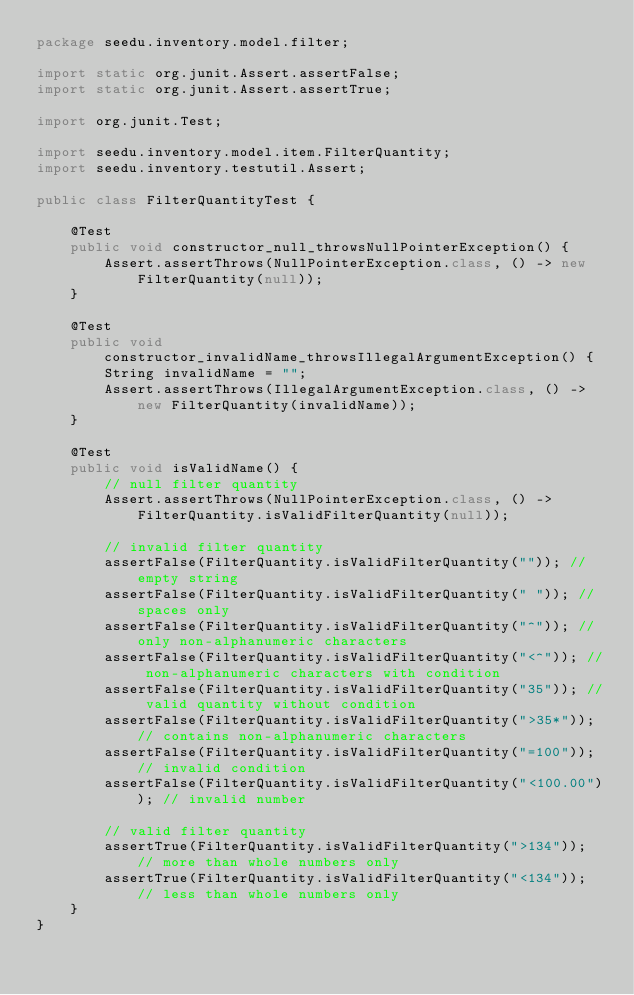<code> <loc_0><loc_0><loc_500><loc_500><_Java_>package seedu.inventory.model.filter;

import static org.junit.Assert.assertFalse;
import static org.junit.Assert.assertTrue;

import org.junit.Test;

import seedu.inventory.model.item.FilterQuantity;
import seedu.inventory.testutil.Assert;

public class FilterQuantityTest {

    @Test
    public void constructor_null_throwsNullPointerException() {
        Assert.assertThrows(NullPointerException.class, () -> new FilterQuantity(null));
    }

    @Test
    public void constructor_invalidName_throwsIllegalArgumentException() {
        String invalidName = "";
        Assert.assertThrows(IllegalArgumentException.class, () -> new FilterQuantity(invalidName));
    }

    @Test
    public void isValidName() {
        // null filter quantity
        Assert.assertThrows(NullPointerException.class, () -> FilterQuantity.isValidFilterQuantity(null));

        // invalid filter quantity
        assertFalse(FilterQuantity.isValidFilterQuantity("")); // empty string
        assertFalse(FilterQuantity.isValidFilterQuantity(" ")); // spaces only
        assertFalse(FilterQuantity.isValidFilterQuantity("^")); // only non-alphanumeric characters
        assertFalse(FilterQuantity.isValidFilterQuantity("<^")); // non-alphanumeric characters with condition
        assertFalse(FilterQuantity.isValidFilterQuantity("35")); // valid quantity without condition
        assertFalse(FilterQuantity.isValidFilterQuantity(">35*")); // contains non-alphanumeric characters
        assertFalse(FilterQuantity.isValidFilterQuantity("=100")); // invalid condition
        assertFalse(FilterQuantity.isValidFilterQuantity("<100.00")); // invalid number

        // valid filter quantity
        assertTrue(FilterQuantity.isValidFilterQuantity(">134")); // more than whole numbers only
        assertTrue(FilterQuantity.isValidFilterQuantity("<134")); // less than whole numbers only
    }
}
</code> 